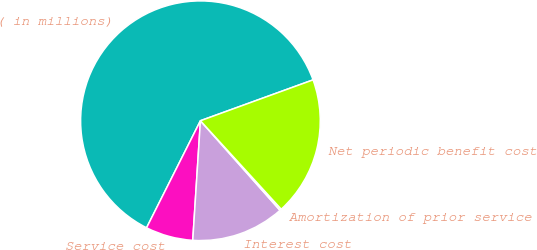<chart> <loc_0><loc_0><loc_500><loc_500><pie_chart><fcel>( in millions)<fcel>Service cost<fcel>Interest cost<fcel>Amortization of prior service<fcel>Net periodic benefit cost<nl><fcel>62.04%<fcel>6.4%<fcel>12.58%<fcel>0.22%<fcel>18.76%<nl></chart> 